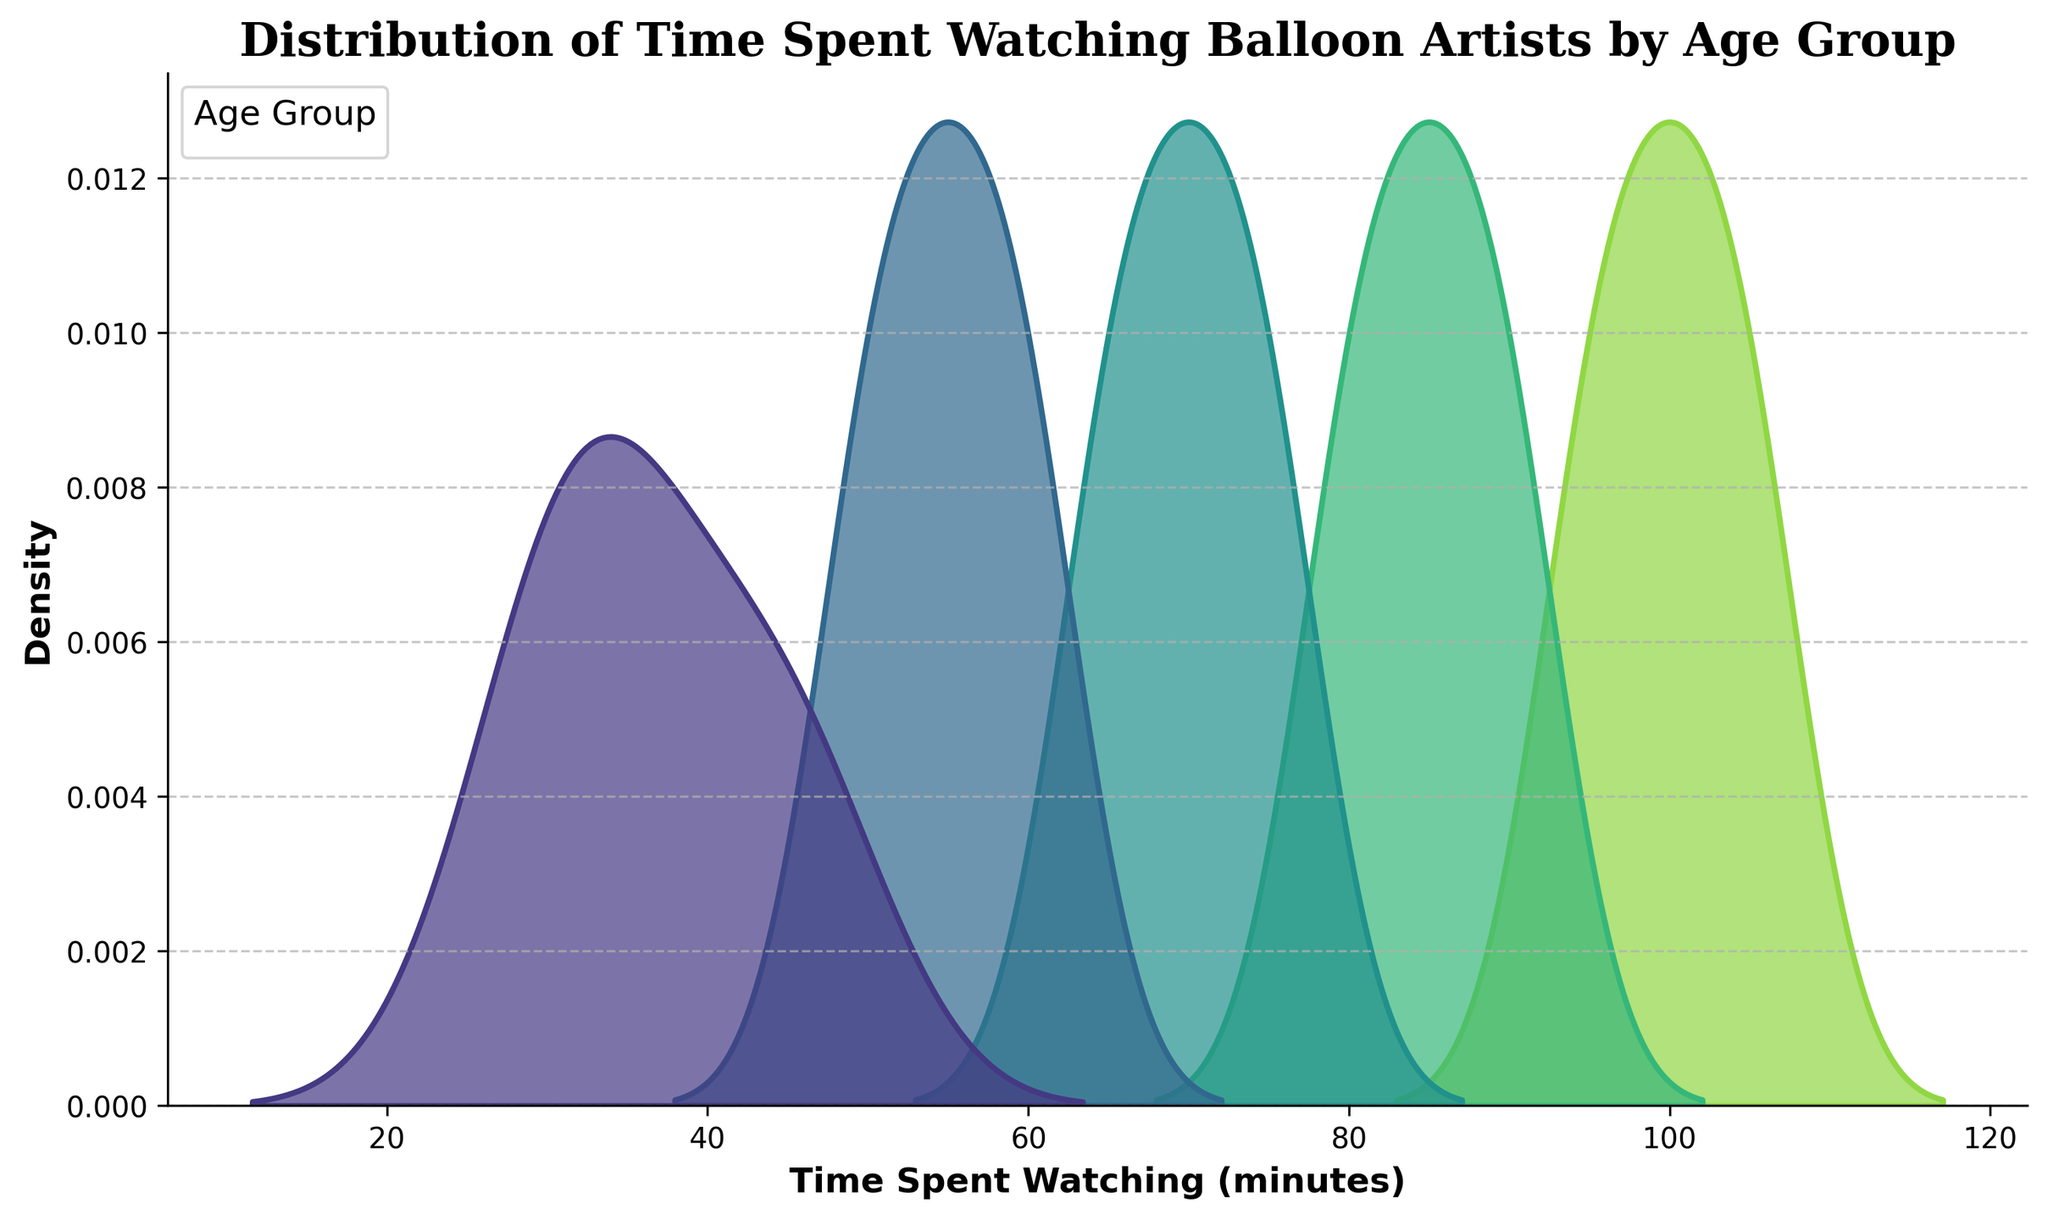What is the title of the figure? The title of the figure is located at the top of the plot, and it helps identify what the plot is about.
Answer: Distribution of Time Spent Watching Balloon Artists by Age Group Which age group has the longest distribution tail towards higher time spent watching? The longest distribution tail towards higher time spent denotes that age group has more people watching for longer times. Looking at the plot, the group 80-85 shows this trend.
Answer: 80-85 At what time spent watching does the age group 70-75 peak? To determine the peak point for any age group, look at the highest point in their respective humps on the plot. For 70-75, this peak is around 70 minutes.
Answer: 70 minutes How does the distribution shape of 65-70 compare with that of 80-85? To compare the shapes, observe the spread and peaks of each age group's curves. The 65-70 age group has a narrower spread with peaks between 50 and 60 minutes, while the 80-85 group shows a broader spread from 95 to 105 minutes.
Answer: 65-70: Narrower, 80-85: Broader Which age group has the least time spent watching? To find this, look at the starting point of the distributions on the x-axis. The distribution for 60-65 starts at 30 minutes, the lowest among all groups.
Answer: 60-65 What is the mean time spent watching for the age group 75-80? While a precise calculation isn’t possible from the plot, you can approximate the mean by estimating the center of the distribution. For 75-80, the peak and center are around 85 minutes.
Answer: 85 minutes Which two age groups have overlapping distributions around 70 minutes? Look at the x-axis around 70 minutes and identify the distributions that intersect. The 65-70 and 70-75 age groups both have distributions peaking or significantly present around 70 minutes.
Answer: 65-70 and 70-75 At what time spent watching does the age group 60-65 start to decrease significantly in density? The density for the 60-65 group starts decreasing significantly after its peak, which is around 45 minutes.
Answer: Around 45 minutes Is there an age group that watches the balloon artists for at least 100 minutes? To determine this, look for the age groups whose distributions extend beyond 100 minutes. The group 80-85 does.
Answer: Yes, 80-85 How does the density of people watching for 50 minutes compare between 60-65 and 75-80 age groups? To compare densities at a specific time, examine the height of the curves at 50 minutes. The group 60-65 has a higher density than 75-80 at 50 minutes.
Answer: 60-65 has higher density 